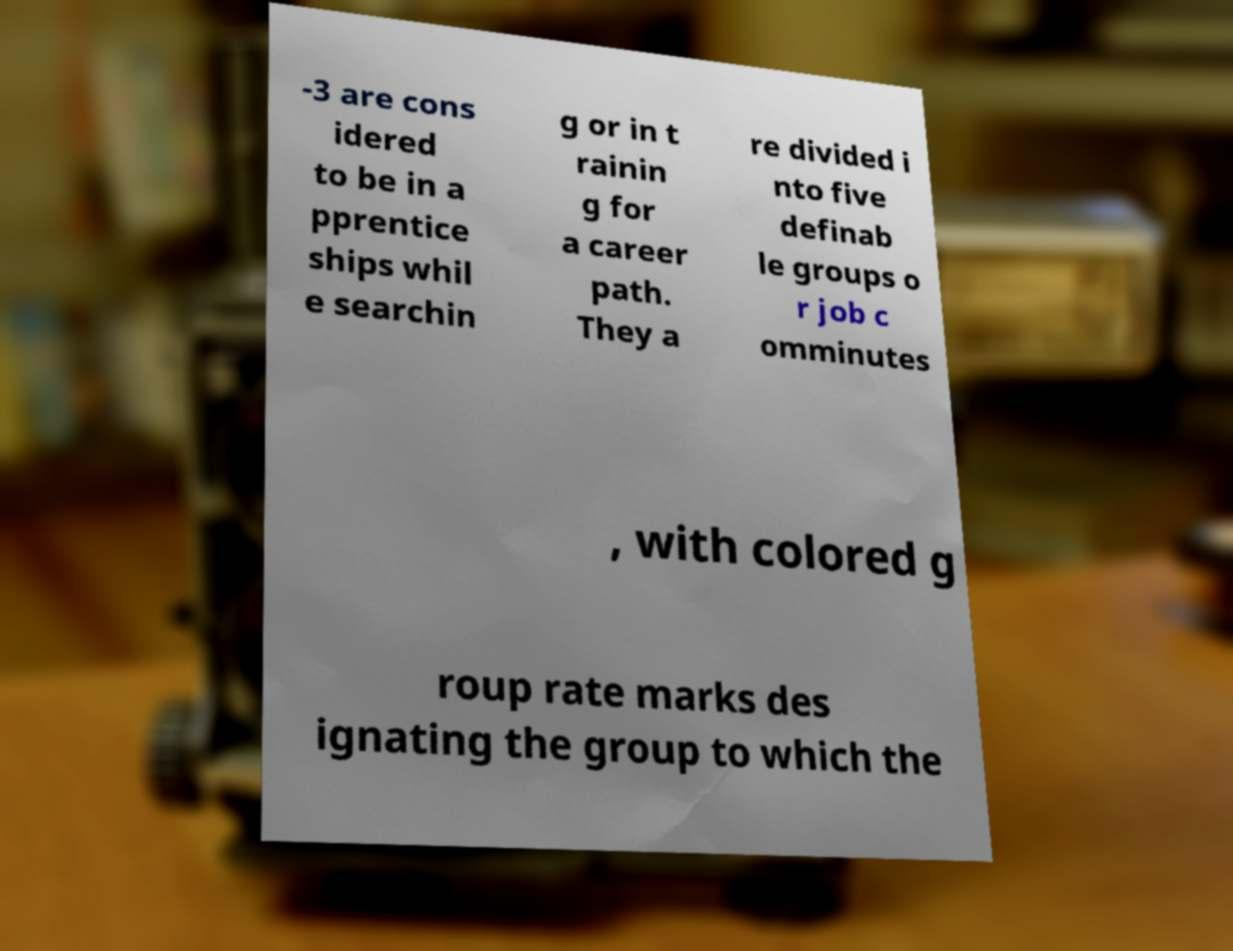I need the written content from this picture converted into text. Can you do that? -3 are cons idered to be in a pprentice ships whil e searchin g or in t rainin g for a career path. They a re divided i nto five definab le groups o r job c omminutes , with colored g roup rate marks des ignating the group to which the 